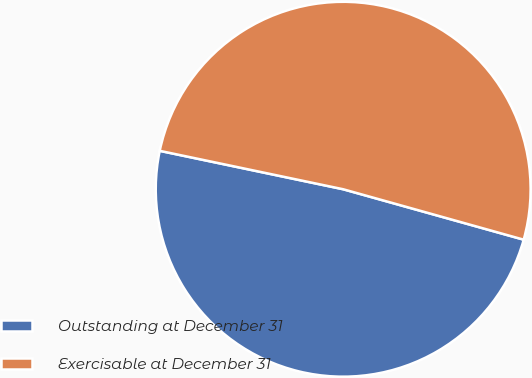<chart> <loc_0><loc_0><loc_500><loc_500><pie_chart><fcel>Outstanding at December 31<fcel>Exercisable at December 31<nl><fcel>48.95%<fcel>51.05%<nl></chart> 